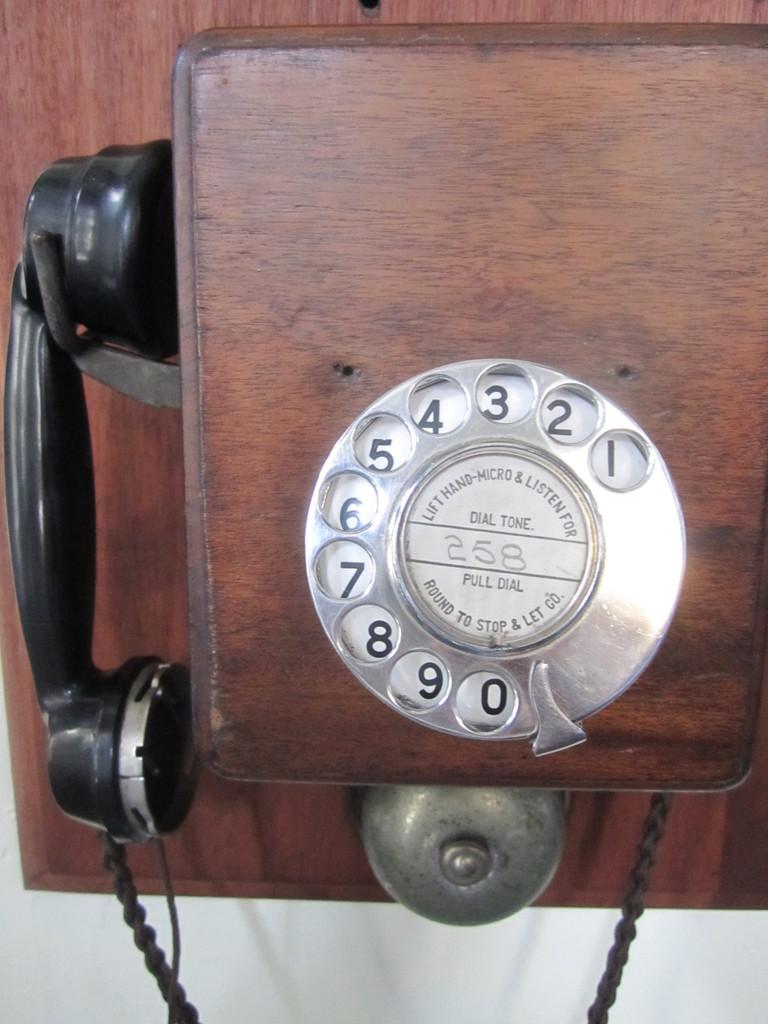Provide a one-sentence caption for the provided image. a telephone with 258 written in the middle of it. 